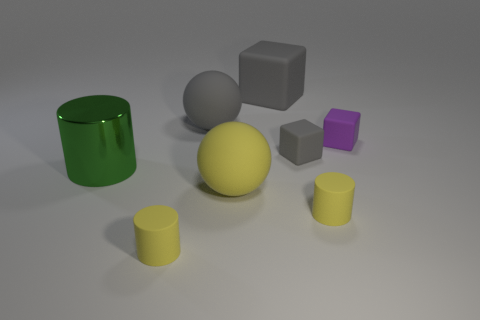There is a small cube that is the same color as the big rubber cube; what is it made of?
Ensure brevity in your answer.  Rubber. There is a tiny gray object that is the same material as the small purple thing; what is its shape?
Your answer should be very brief. Cube. What color is the matte object that is to the right of the small gray cube and in front of the big green shiny cylinder?
Ensure brevity in your answer.  Yellow. Does the sphere in front of the purple matte object have the same material as the green thing?
Offer a very short reply. No. Is the number of big matte balls behind the big gray sphere less than the number of large yellow rubber balls?
Your response must be concise. Yes. Are there any cyan spheres that have the same material as the big green cylinder?
Keep it short and to the point. No. There is a metallic object; is it the same size as the ball in front of the big green object?
Your answer should be compact. Yes. Are there any small matte cubes of the same color as the metallic cylinder?
Keep it short and to the point. No. Does the large green thing have the same material as the gray ball?
Provide a succinct answer. No. There is a big yellow object; how many rubber spheres are behind it?
Provide a succinct answer. 1. 